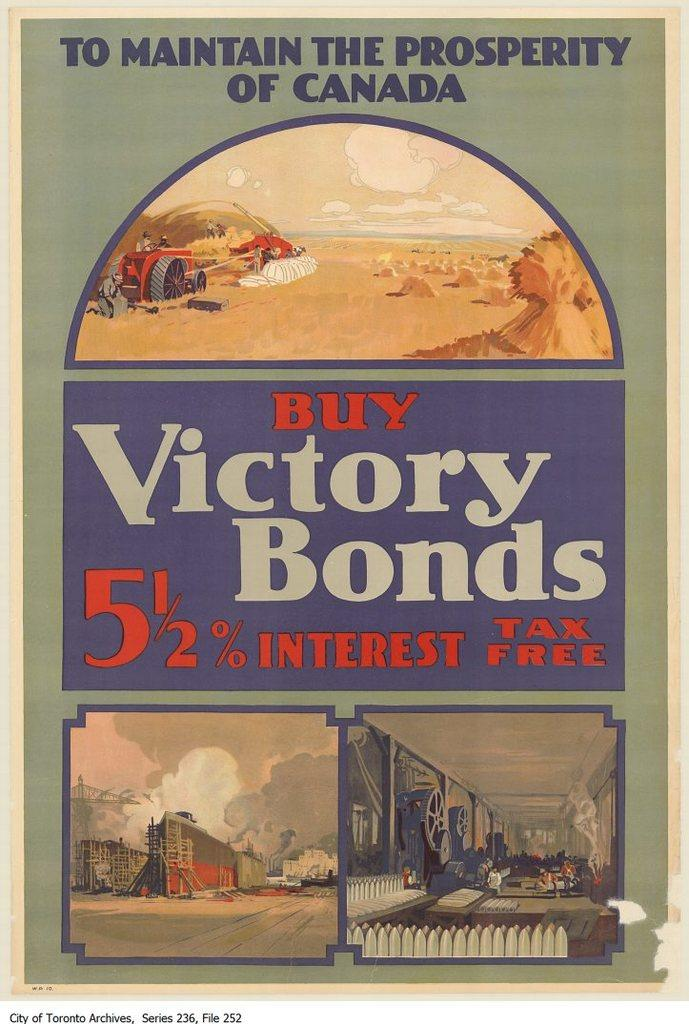<image>
Present a compact description of the photo's key features. A poster that says Buy Victory bonds tax free. 